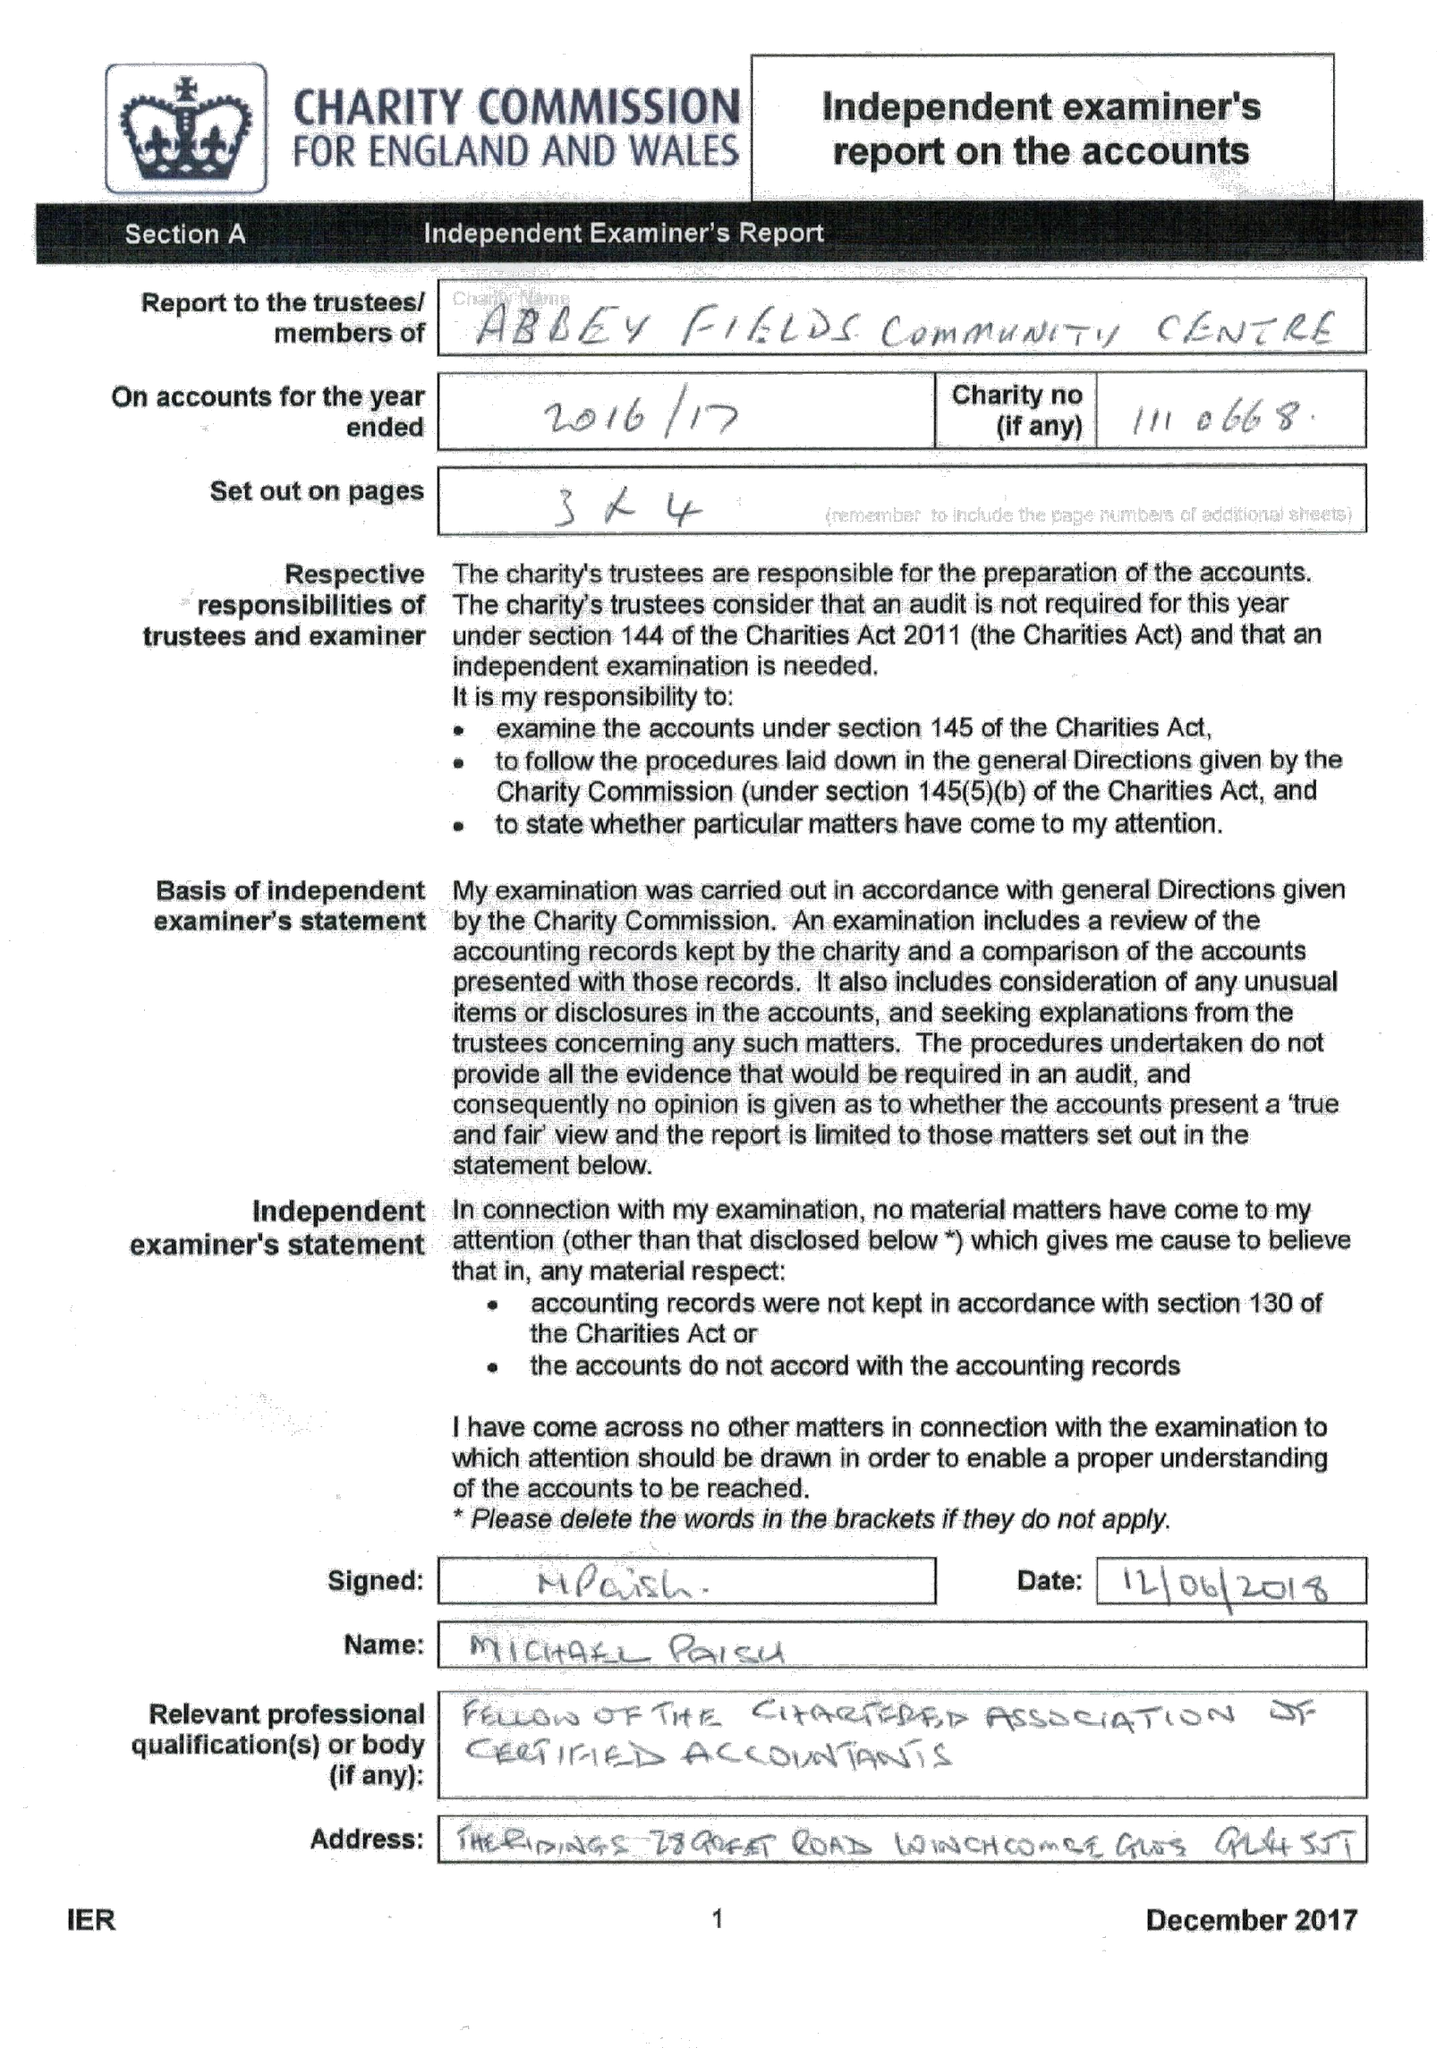What is the value for the charity_name?
Answer the question using a single word or phrase. Abbey Fields Community Centre 